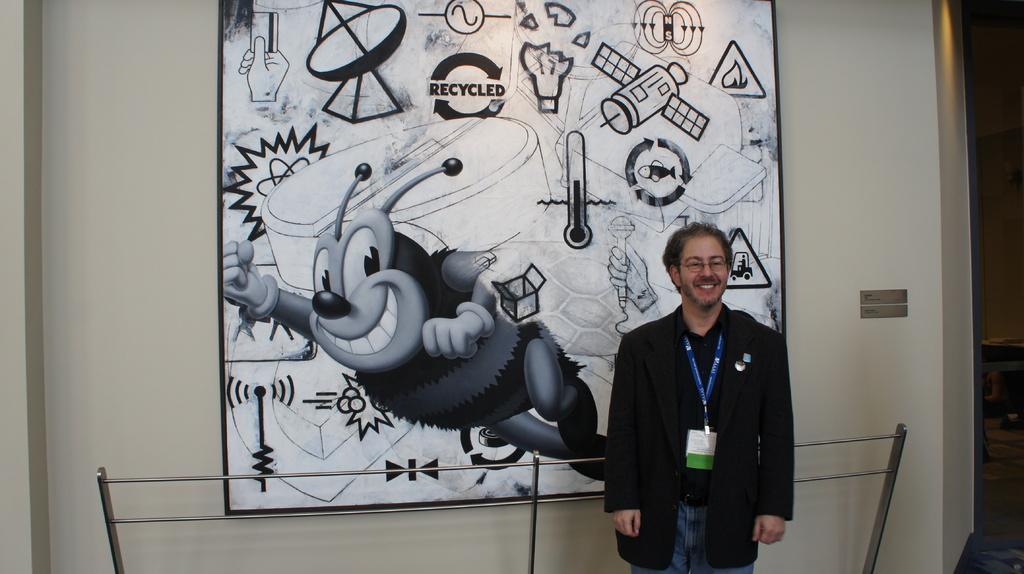Can you describe this image briefly? In this image I can see a man is standing on the right side and I can see he is wearing blazer, specs and an ID card. I can also see smile on his face. Behind him I can see railing and a frame on the wall. I can also see this frame contains number of black and white colour things. 